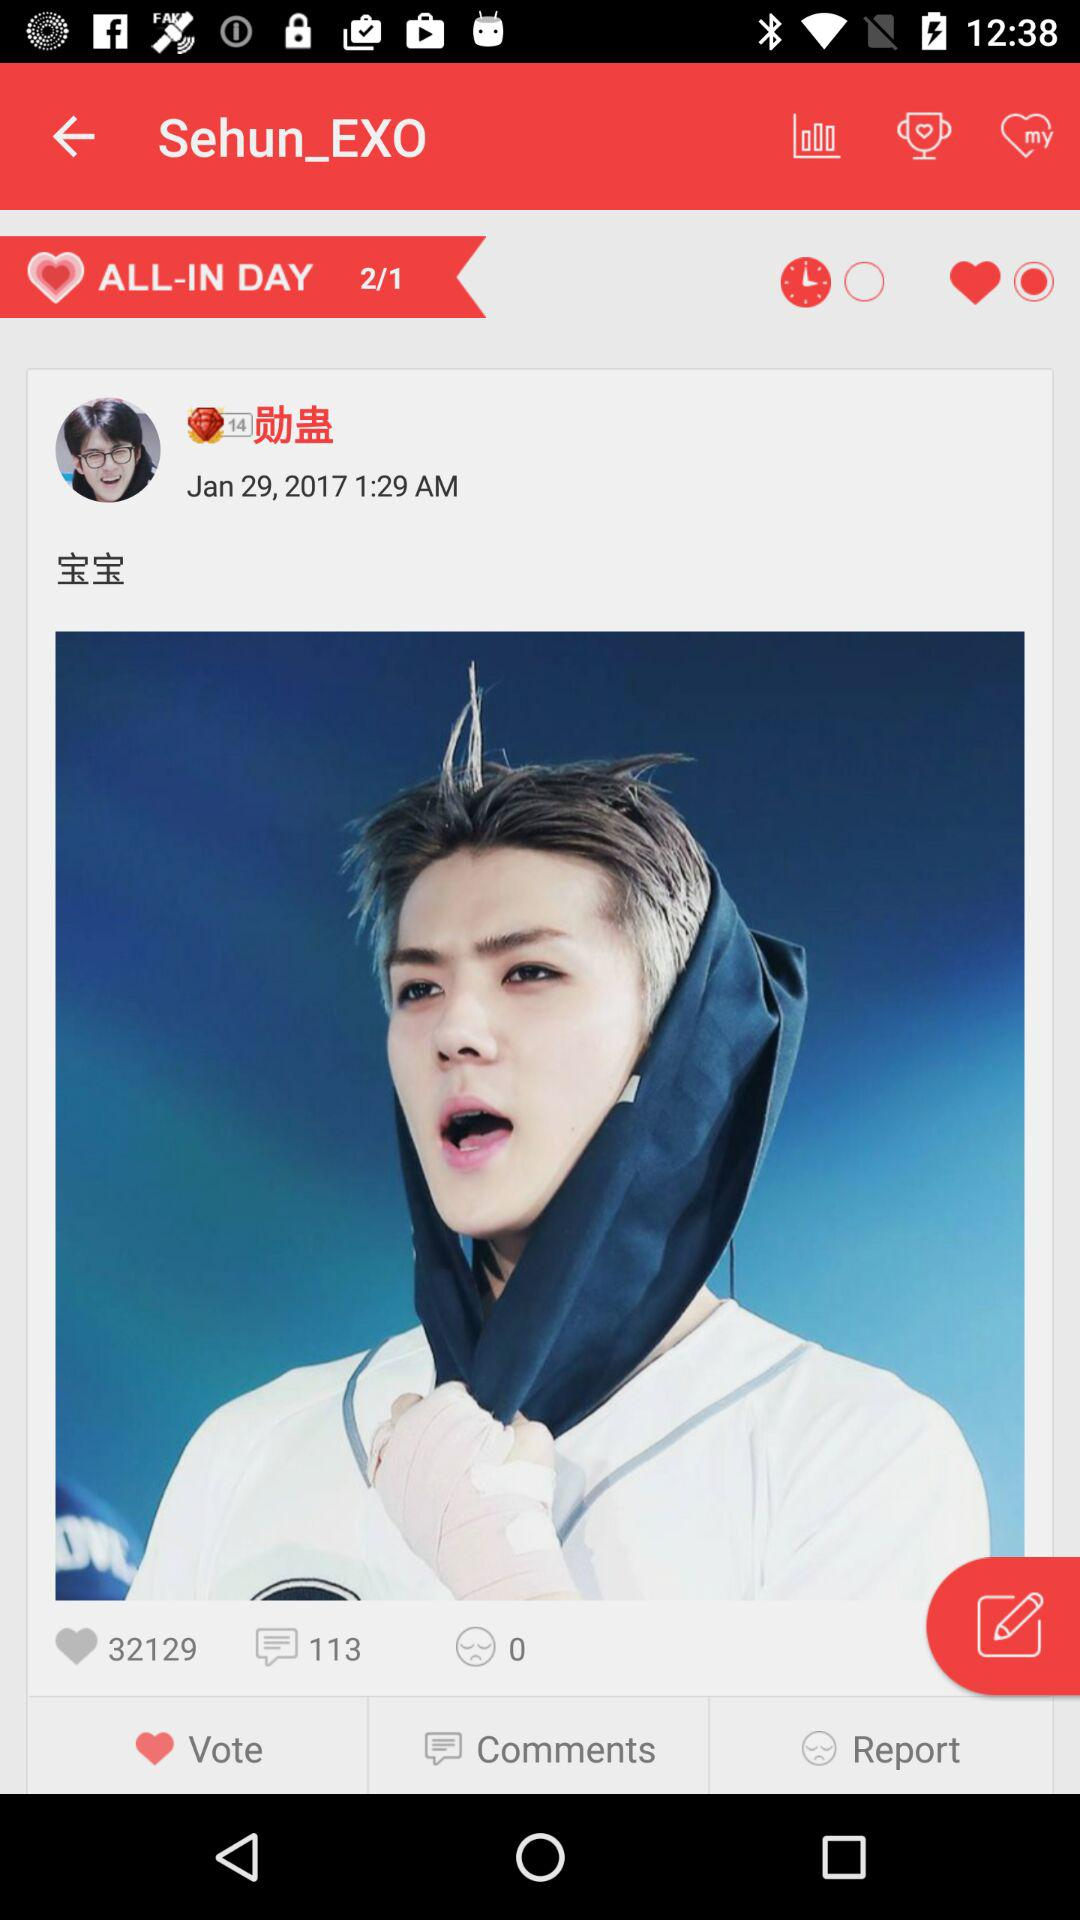What is the given date? The given date is January 29, 2017. 